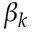Convert formula to latex. <formula><loc_0><loc_0><loc_500><loc_500>\beta _ { k }</formula> 